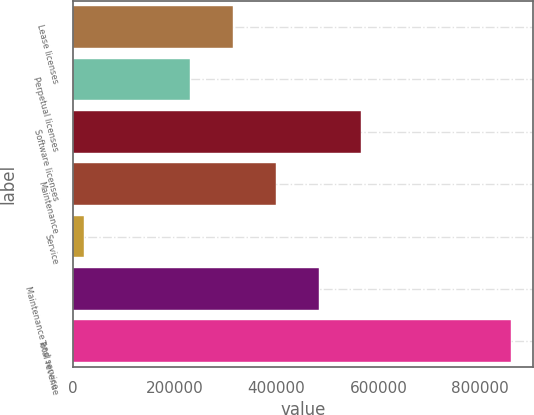<chart> <loc_0><loc_0><loc_500><loc_500><bar_chart><fcel>Lease licenses<fcel>Perpetual licenses<fcel>Software licenses<fcel>Maintenance<fcel>Service<fcel>Maintenance and service<fcel>Total revenue<nl><fcel>315089<fcel>231286<fcel>566498<fcel>398892<fcel>23231<fcel>482695<fcel>861260<nl></chart> 